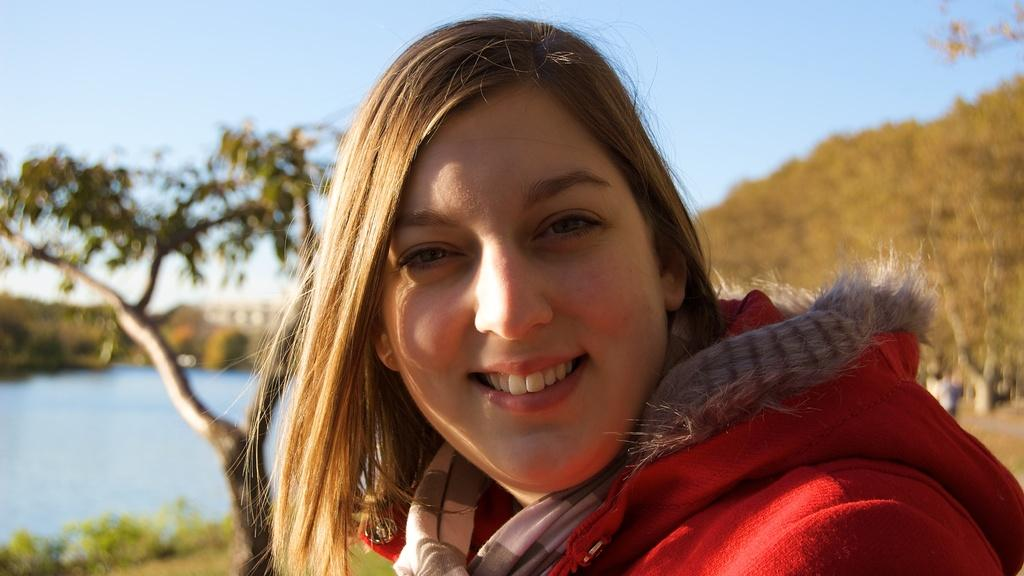Who is present in the image? There is a woman in the image. What is the woman wearing? The woman is wearing a red coat. What can be seen on the left side of the image? There are trees and water on the left side of the image. What can be seen on the right side of the image? There are trees on the right side of the image. What is visible at the top of the image? The sky is visible at the top of the image. What type of market can be seen in the image? There is no market present in the image; it features a woman and a landscape with trees, water, and sky. What activity is the woman engaged in with the lock in the image? There is no lock present in the image, and the woman's activity is not specified. 